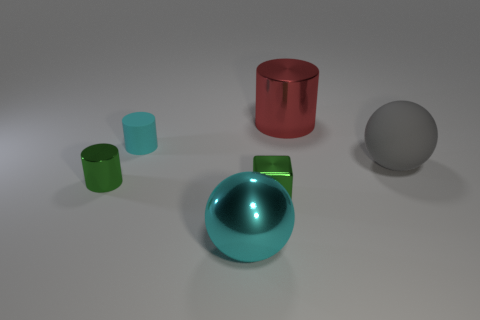Is the size of the matte sphere the same as the ball that is to the left of the gray object?
Give a very brief answer. Yes. What size is the other object that is the same shape as the large cyan shiny object?
Offer a terse response. Large. Are there any other things that have the same material as the red cylinder?
Your answer should be compact. Yes. There is a shiny thing in front of the small green metallic cube; does it have the same size as the cylinder on the right side of the small cyan cylinder?
Your answer should be very brief. Yes. What number of large objects are either green metal blocks or green objects?
Keep it short and to the point. 0. How many shiny things are behind the large cyan metallic ball and in front of the red metallic thing?
Your response must be concise. 2. Are there an equal number of green shiny cylinders and small green shiny objects?
Offer a terse response. No. Are the tiny cyan cylinder and the tiny block in front of the big matte sphere made of the same material?
Your answer should be very brief. No. How many red objects are spheres or large cylinders?
Your answer should be very brief. 1. Is there a red metal object that has the same size as the green cylinder?
Keep it short and to the point. No. 